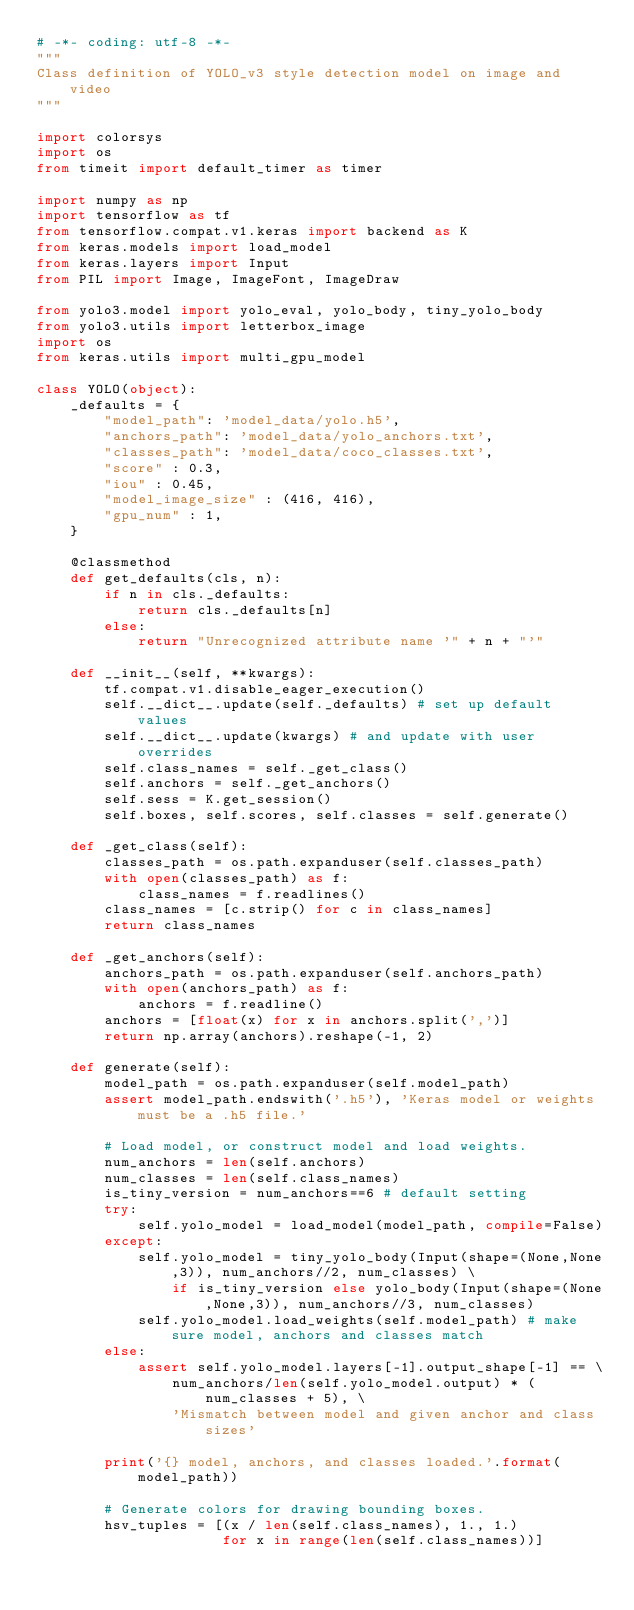<code> <loc_0><loc_0><loc_500><loc_500><_Python_># -*- coding: utf-8 -*-
"""
Class definition of YOLO_v3 style detection model on image and video
"""

import colorsys
import os
from timeit import default_timer as timer

import numpy as np
import tensorflow as tf
from tensorflow.compat.v1.keras import backend as K
from keras.models import load_model
from keras.layers import Input
from PIL import Image, ImageFont, ImageDraw

from yolo3.model import yolo_eval, yolo_body, tiny_yolo_body
from yolo3.utils import letterbox_image
import os
from keras.utils import multi_gpu_model

class YOLO(object):
    _defaults = {
        "model_path": 'model_data/yolo.h5',
        "anchors_path": 'model_data/yolo_anchors.txt',
        "classes_path": 'model_data/coco_classes.txt',
        "score" : 0.3,
        "iou" : 0.45,
        "model_image_size" : (416, 416),
        "gpu_num" : 1,
    }

    @classmethod
    def get_defaults(cls, n):
        if n in cls._defaults:
            return cls._defaults[n]
        else:
            return "Unrecognized attribute name '" + n + "'"

    def __init__(self, **kwargs):
        tf.compat.v1.disable_eager_execution()
        self.__dict__.update(self._defaults) # set up default values
        self.__dict__.update(kwargs) # and update with user overrides
        self.class_names = self._get_class()
        self.anchors = self._get_anchors()
        self.sess = K.get_session()
        self.boxes, self.scores, self.classes = self.generate()

    def _get_class(self):
        classes_path = os.path.expanduser(self.classes_path)
        with open(classes_path) as f:
            class_names = f.readlines()
        class_names = [c.strip() for c in class_names]
        return class_names

    def _get_anchors(self):
        anchors_path = os.path.expanduser(self.anchors_path)
        with open(anchors_path) as f:
            anchors = f.readline()
        anchors = [float(x) for x in anchors.split(',')]
        return np.array(anchors).reshape(-1, 2)

    def generate(self):
        model_path = os.path.expanduser(self.model_path)
        assert model_path.endswith('.h5'), 'Keras model or weights must be a .h5 file.'

        # Load model, or construct model and load weights.
        num_anchors = len(self.anchors)
        num_classes = len(self.class_names)
        is_tiny_version = num_anchors==6 # default setting
        try:
            self.yolo_model = load_model(model_path, compile=False)
        except:
            self.yolo_model = tiny_yolo_body(Input(shape=(None,None,3)), num_anchors//2, num_classes) \
                if is_tiny_version else yolo_body(Input(shape=(None,None,3)), num_anchors//3, num_classes)
            self.yolo_model.load_weights(self.model_path) # make sure model, anchors and classes match
        else:
            assert self.yolo_model.layers[-1].output_shape[-1] == \
                num_anchors/len(self.yolo_model.output) * (num_classes + 5), \
                'Mismatch between model and given anchor and class sizes'

        print('{} model, anchors, and classes loaded.'.format(model_path))

        # Generate colors for drawing bounding boxes.
        hsv_tuples = [(x / len(self.class_names), 1., 1.)
                      for x in range(len(self.class_names))]</code> 